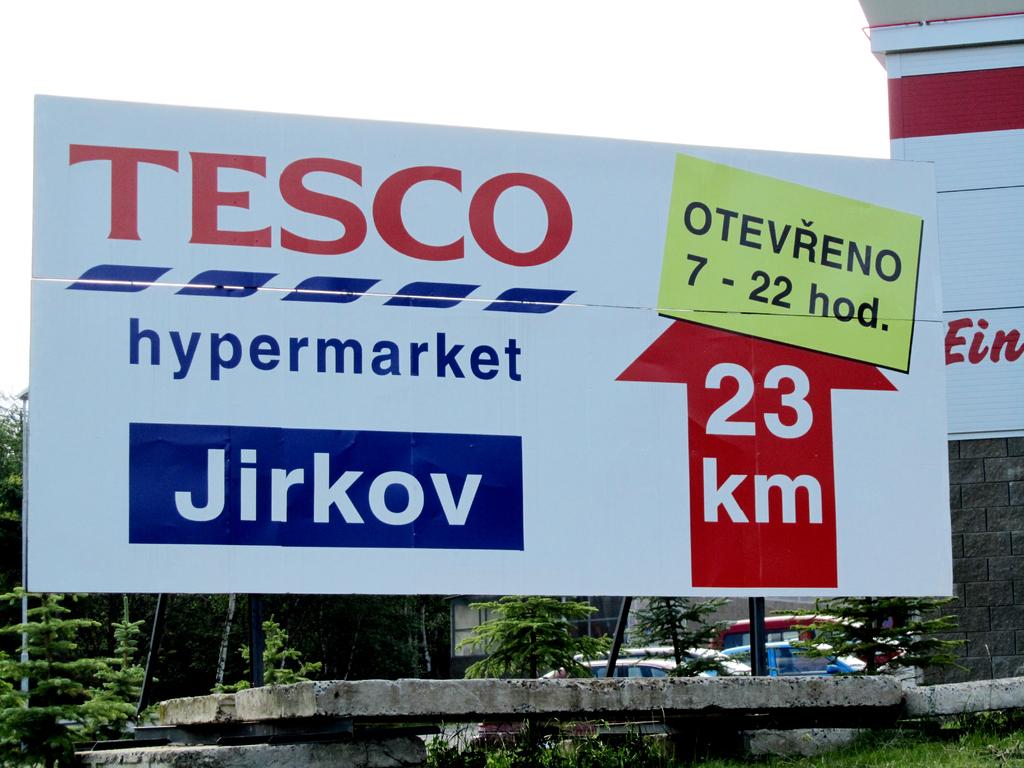Which market is on the billboard?
Give a very brief answer. Tesco. What is the km?
Give a very brief answer. 23. 